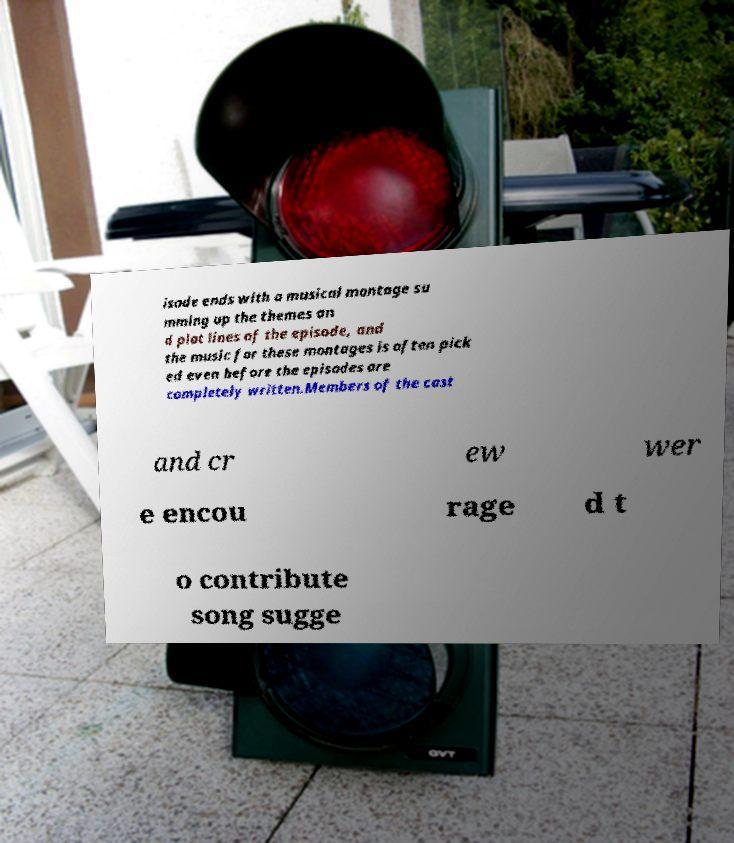Please identify and transcribe the text found in this image. isode ends with a musical montage su mming up the themes an d plot lines of the episode, and the music for these montages is often pick ed even before the episodes are completely written.Members of the cast and cr ew wer e encou rage d t o contribute song sugge 